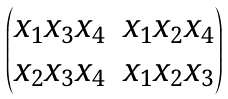<formula> <loc_0><loc_0><loc_500><loc_500>\begin{pmatrix} x _ { 1 } x _ { 3 } x _ { 4 } & x _ { 1 } x _ { 2 } x _ { 4 } \\ x _ { 2 } x _ { 3 } x _ { 4 } & x _ { 1 } x _ { 2 } x _ { 3 } \end{pmatrix}</formula> 